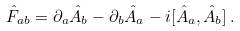Convert formula to latex. <formula><loc_0><loc_0><loc_500><loc_500>\hat { F } _ { a b } = \partial _ { a } \hat { A } _ { b } - \partial _ { b } \hat { A } _ { a } - i [ \hat { A } _ { a } , \hat { A } _ { b } ] \, .</formula> 